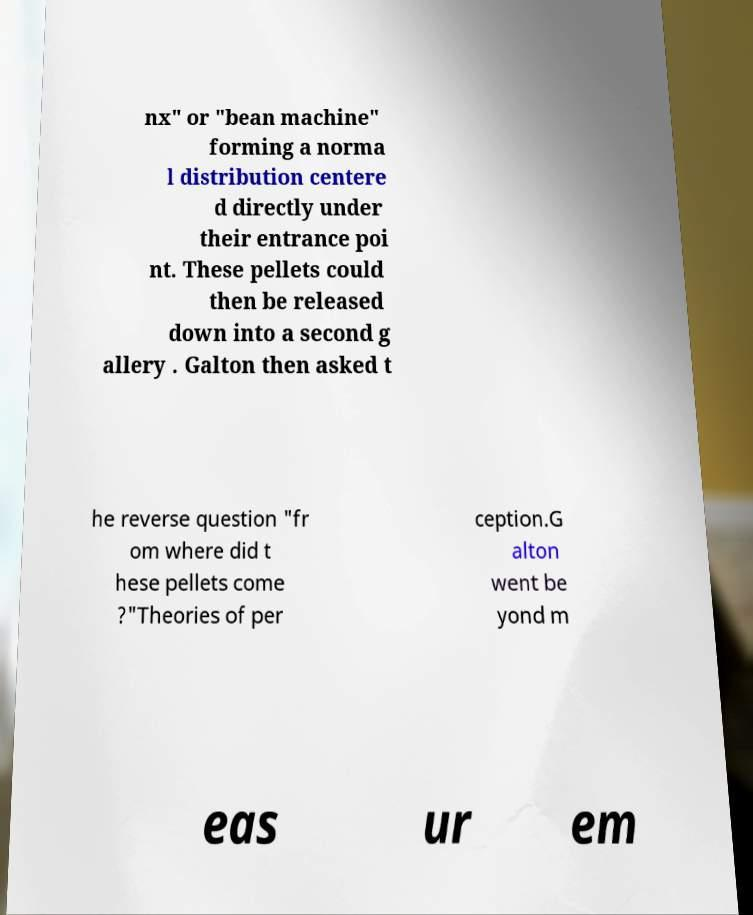For documentation purposes, I need the text within this image transcribed. Could you provide that? nx" or "bean machine" forming a norma l distribution centere d directly under their entrance poi nt. These pellets could then be released down into a second g allery . Galton then asked t he reverse question "fr om where did t hese pellets come ?"Theories of per ception.G alton went be yond m eas ur em 